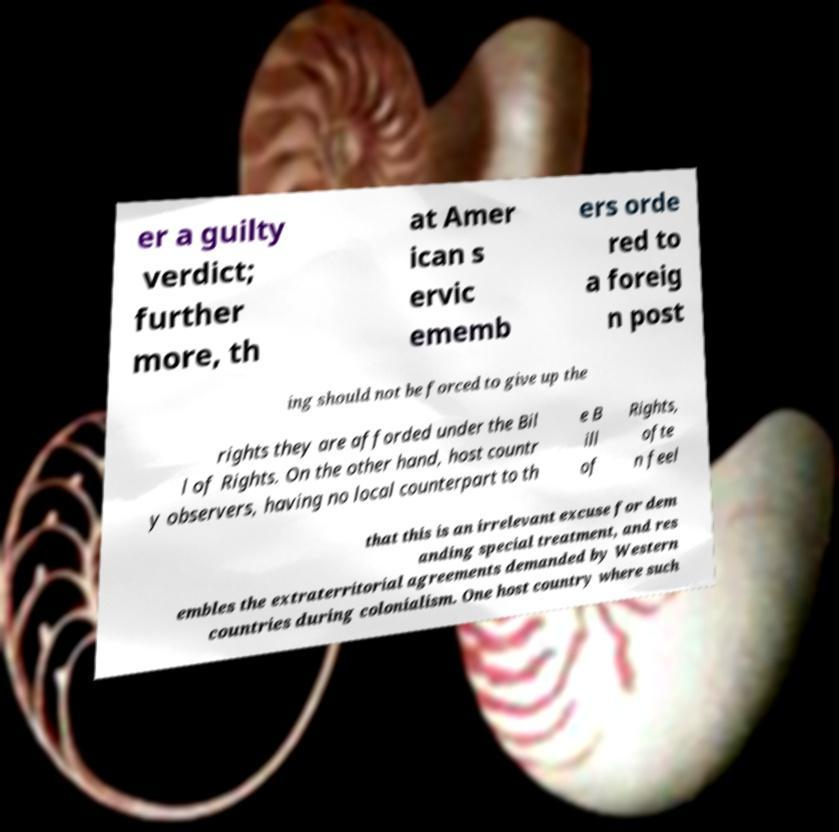Could you assist in decoding the text presented in this image and type it out clearly? er a guilty verdict; further more, th at Amer ican s ervic ememb ers orde red to a foreig n post ing should not be forced to give up the rights they are afforded under the Bil l of Rights. On the other hand, host countr y observers, having no local counterpart to th e B ill of Rights, ofte n feel that this is an irrelevant excuse for dem anding special treatment, and res embles the extraterritorial agreements demanded by Western countries during colonialism. One host country where such 